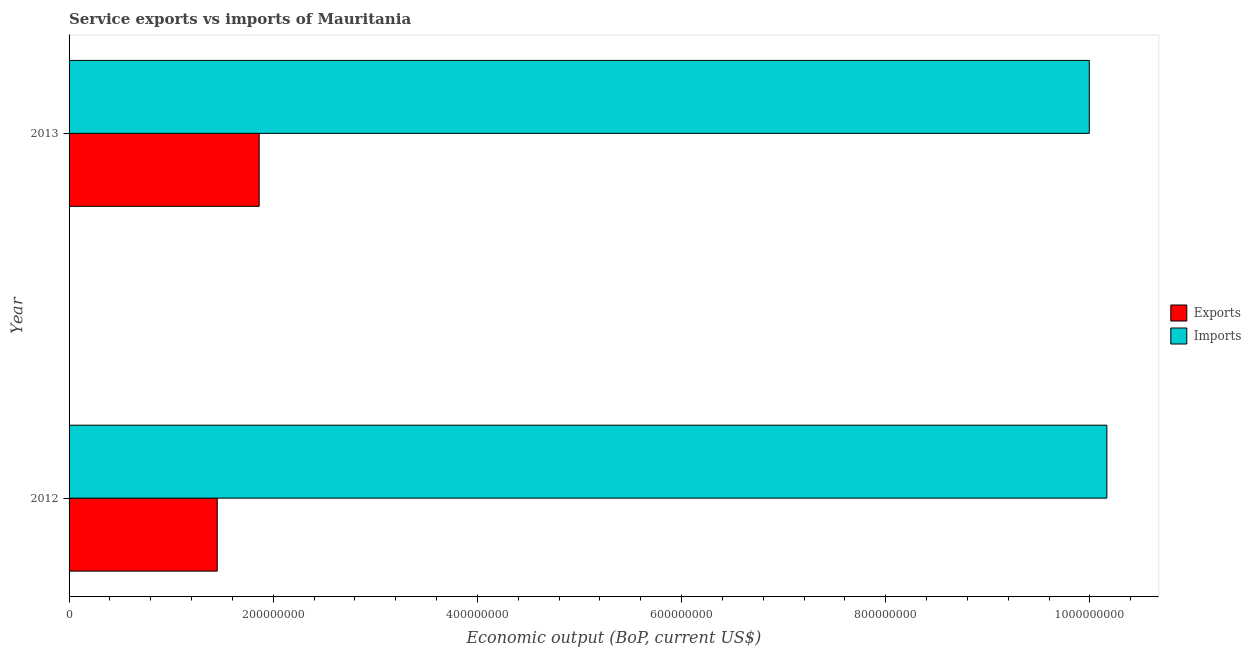How many groups of bars are there?
Your answer should be very brief. 2. How many bars are there on the 2nd tick from the top?
Make the answer very short. 2. How many bars are there on the 2nd tick from the bottom?
Ensure brevity in your answer.  2. What is the amount of service imports in 2013?
Provide a succinct answer. 9.99e+08. Across all years, what is the maximum amount of service imports?
Offer a very short reply. 1.02e+09. Across all years, what is the minimum amount of service imports?
Make the answer very short. 9.99e+08. In which year was the amount of service imports maximum?
Provide a succinct answer. 2012. In which year was the amount of service imports minimum?
Your answer should be very brief. 2013. What is the total amount of service exports in the graph?
Keep it short and to the point. 3.31e+08. What is the difference between the amount of service exports in 2012 and that in 2013?
Offer a terse response. -4.11e+07. What is the difference between the amount of service imports in 2012 and the amount of service exports in 2013?
Make the answer very short. 8.30e+08. What is the average amount of service exports per year?
Provide a succinct answer. 1.66e+08. In the year 2012, what is the difference between the amount of service exports and amount of service imports?
Provide a succinct answer. -8.72e+08. In how many years, is the amount of service exports greater than 400000000 US$?
Make the answer very short. 0. What is the ratio of the amount of service exports in 2012 to that in 2013?
Offer a very short reply. 0.78. In how many years, is the amount of service exports greater than the average amount of service exports taken over all years?
Provide a short and direct response. 1. What does the 1st bar from the top in 2012 represents?
Your response must be concise. Imports. What does the 1st bar from the bottom in 2012 represents?
Provide a succinct answer. Exports. Are all the bars in the graph horizontal?
Your response must be concise. Yes. How many years are there in the graph?
Offer a very short reply. 2. What is the difference between two consecutive major ticks on the X-axis?
Ensure brevity in your answer.  2.00e+08. Where does the legend appear in the graph?
Keep it short and to the point. Center right. How many legend labels are there?
Give a very brief answer. 2. What is the title of the graph?
Provide a succinct answer. Service exports vs imports of Mauritania. Does "ODA received" appear as one of the legend labels in the graph?
Offer a very short reply. No. What is the label or title of the X-axis?
Give a very brief answer. Economic output (BoP, current US$). What is the Economic output (BoP, current US$) of Exports in 2012?
Offer a very short reply. 1.45e+08. What is the Economic output (BoP, current US$) of Imports in 2012?
Make the answer very short. 1.02e+09. What is the Economic output (BoP, current US$) of Exports in 2013?
Offer a terse response. 1.86e+08. What is the Economic output (BoP, current US$) in Imports in 2013?
Make the answer very short. 9.99e+08. Across all years, what is the maximum Economic output (BoP, current US$) in Exports?
Your response must be concise. 1.86e+08. Across all years, what is the maximum Economic output (BoP, current US$) in Imports?
Keep it short and to the point. 1.02e+09. Across all years, what is the minimum Economic output (BoP, current US$) in Exports?
Your answer should be very brief. 1.45e+08. Across all years, what is the minimum Economic output (BoP, current US$) of Imports?
Make the answer very short. 9.99e+08. What is the total Economic output (BoP, current US$) in Exports in the graph?
Make the answer very short. 3.31e+08. What is the total Economic output (BoP, current US$) in Imports in the graph?
Your answer should be compact. 2.02e+09. What is the difference between the Economic output (BoP, current US$) of Exports in 2012 and that in 2013?
Make the answer very short. -4.11e+07. What is the difference between the Economic output (BoP, current US$) in Imports in 2012 and that in 2013?
Your answer should be compact. 1.73e+07. What is the difference between the Economic output (BoP, current US$) in Exports in 2012 and the Economic output (BoP, current US$) in Imports in 2013?
Offer a very short reply. -8.54e+08. What is the average Economic output (BoP, current US$) of Exports per year?
Keep it short and to the point. 1.66e+08. What is the average Economic output (BoP, current US$) in Imports per year?
Keep it short and to the point. 1.01e+09. In the year 2012, what is the difference between the Economic output (BoP, current US$) in Exports and Economic output (BoP, current US$) in Imports?
Offer a terse response. -8.72e+08. In the year 2013, what is the difference between the Economic output (BoP, current US$) in Exports and Economic output (BoP, current US$) in Imports?
Make the answer very short. -8.13e+08. What is the ratio of the Economic output (BoP, current US$) of Exports in 2012 to that in 2013?
Offer a very short reply. 0.78. What is the ratio of the Economic output (BoP, current US$) of Imports in 2012 to that in 2013?
Your answer should be compact. 1.02. What is the difference between the highest and the second highest Economic output (BoP, current US$) of Exports?
Provide a short and direct response. 4.11e+07. What is the difference between the highest and the second highest Economic output (BoP, current US$) in Imports?
Make the answer very short. 1.73e+07. What is the difference between the highest and the lowest Economic output (BoP, current US$) in Exports?
Give a very brief answer. 4.11e+07. What is the difference between the highest and the lowest Economic output (BoP, current US$) in Imports?
Keep it short and to the point. 1.73e+07. 